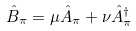Convert formula to latex. <formula><loc_0><loc_0><loc_500><loc_500>\hat { B } _ { \pi } = \mu \hat { A } _ { \pi } + \nu \hat { A } ^ { \dag } _ { \pi }</formula> 